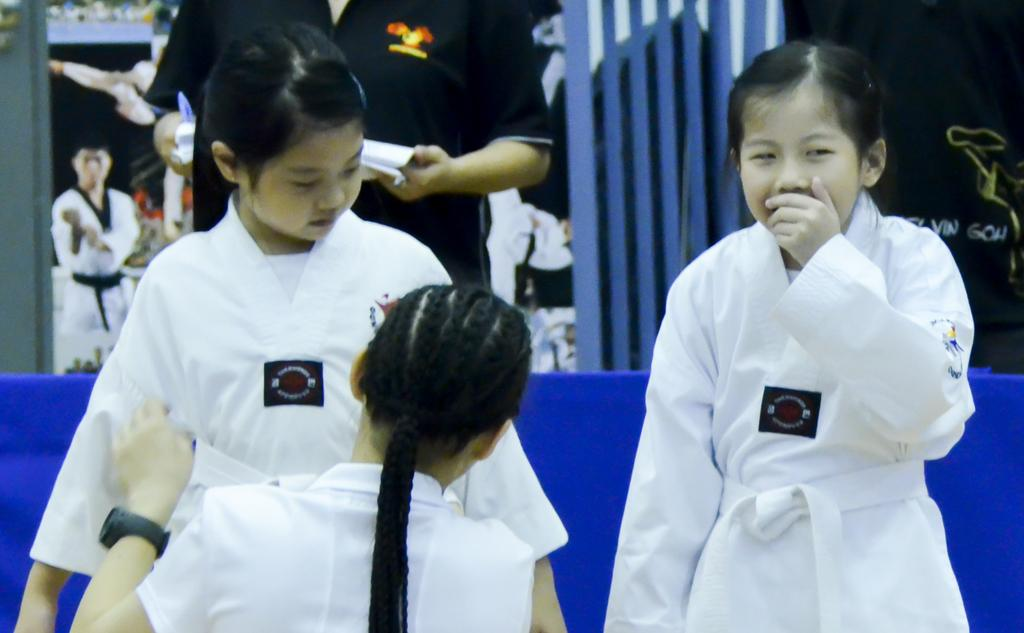What can be seen in the image? There are people standing in the image. Where are the people standing? The people are standing on the floor. What can be seen in the background of the image? There are grills visible in the background of the image. What type of advice can be heard being given in the image? There is no indication in the image that any advice is being given, so it cannot be determined from the picture. 